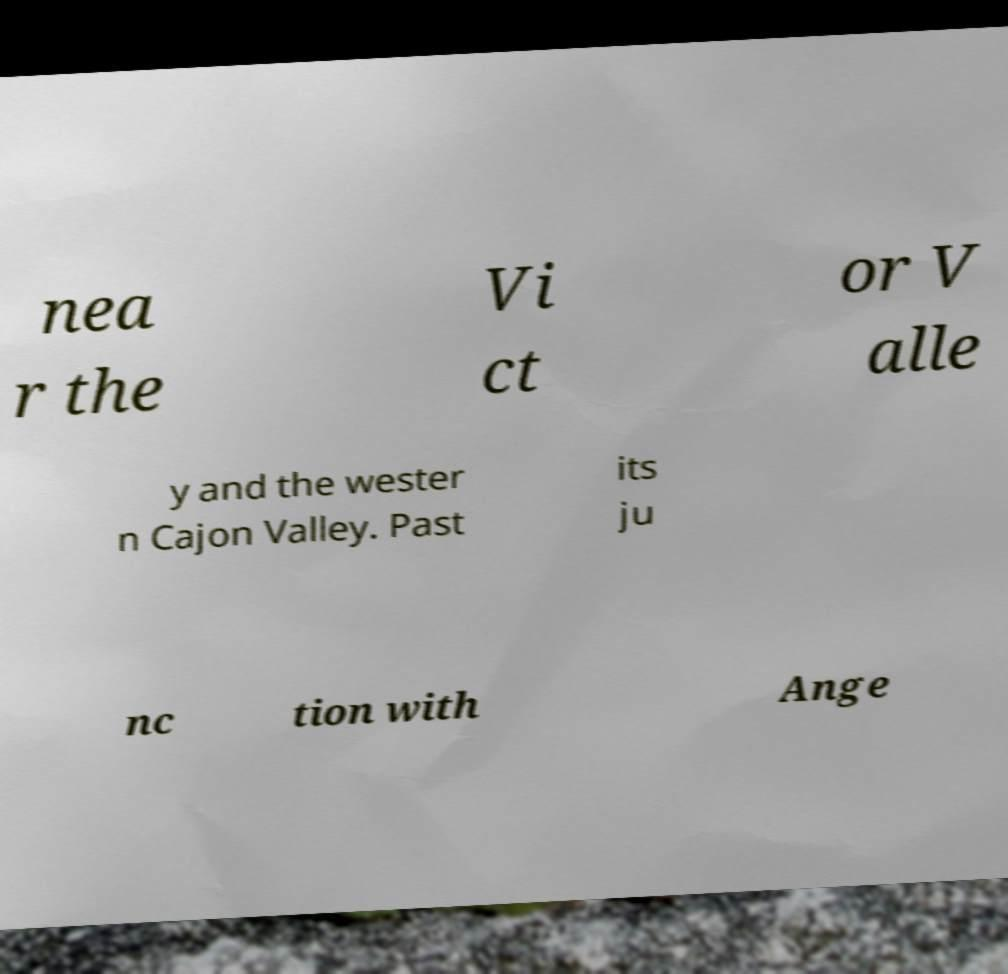Please read and relay the text visible in this image. What does it say? nea r the Vi ct or V alle y and the wester n Cajon Valley. Past its ju nc tion with Ange 